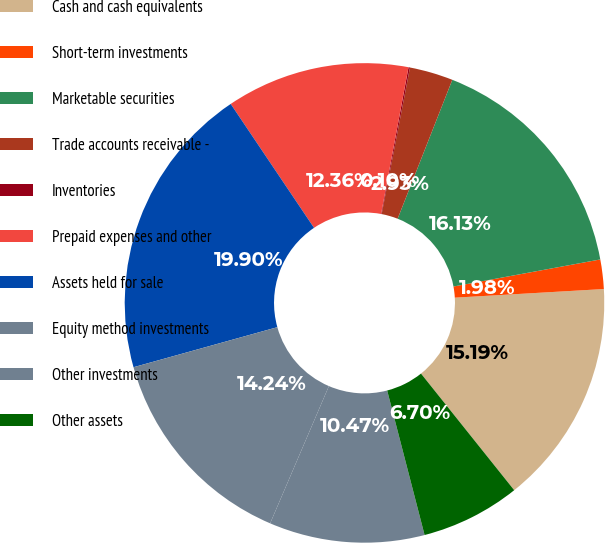Convert chart. <chart><loc_0><loc_0><loc_500><loc_500><pie_chart><fcel>Cash and cash equivalents<fcel>Short-term investments<fcel>Marketable securities<fcel>Trade accounts receivable -<fcel>Inventories<fcel>Prepaid expenses and other<fcel>Assets held for sale<fcel>Equity method investments<fcel>Other investments<fcel>Other assets<nl><fcel>15.19%<fcel>1.98%<fcel>16.13%<fcel>2.93%<fcel>0.1%<fcel>12.36%<fcel>19.9%<fcel>14.24%<fcel>10.47%<fcel>6.7%<nl></chart> 